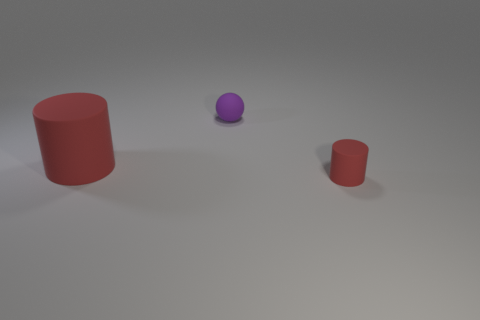Is the number of small red objects in front of the big object greater than the number of tiny red cylinders that are to the left of the ball?
Provide a short and direct response. Yes. What shape is the purple thing that is the same material as the tiny cylinder?
Give a very brief answer. Sphere. Are there more matte objects that are on the left side of the purple thing than big yellow rubber things?
Ensure brevity in your answer.  Yes. How many rubber objects have the same color as the matte ball?
Your response must be concise. 0. How many other objects are there of the same color as the matte sphere?
Your answer should be compact. 0. Are there more purple matte things than matte objects?
Make the answer very short. No. There is a thing on the right side of the purple matte ball; is its size the same as the tiny matte sphere?
Ensure brevity in your answer.  Yes. There is a red rubber object that is to the left of the small red object; what is its size?
Ensure brevity in your answer.  Large. What number of blue rubber balls are there?
Offer a very short reply. 0. Does the tiny cylinder have the same color as the large rubber thing?
Offer a terse response. Yes. 